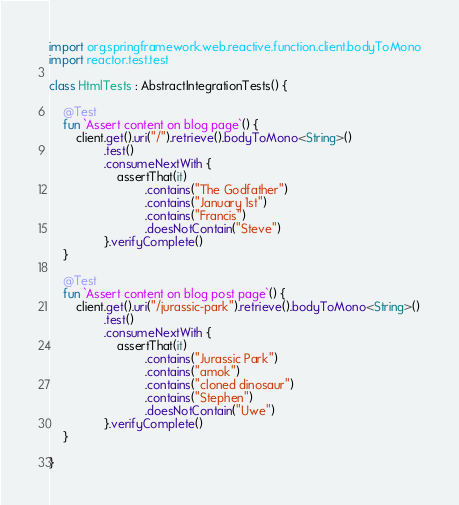Convert code to text. <code><loc_0><loc_0><loc_500><loc_500><_Kotlin_>
import org.springframework.web.reactive.function.client.bodyToMono
import reactor.test.test

class HtmlTests : AbstractIntegrationTests() {

    @Test
    fun `Assert content on blog page`() {
        client.get().uri("/").retrieve().bodyToMono<String>()
                .test()
                .consumeNextWith {
                    assertThat(it)
                            .contains("The Godfather")
                            .contains("January 1st")
                            .contains("Francis")
                            .doesNotContain("Steve")
                }.verifyComplete()
    }

    @Test
    fun `Assert content on blog post page`() {
        client.get().uri("/jurassic-park").retrieve().bodyToMono<String>()
                .test()
                .consumeNextWith {
                    assertThat(it)
                            .contains("Jurassic Park")
                            .contains("amok")
                            .contains("cloned dinosaur")
                            .contains("Stephen")
                            .doesNotContain("Uwe")
                }.verifyComplete()
    }

}
</code> 